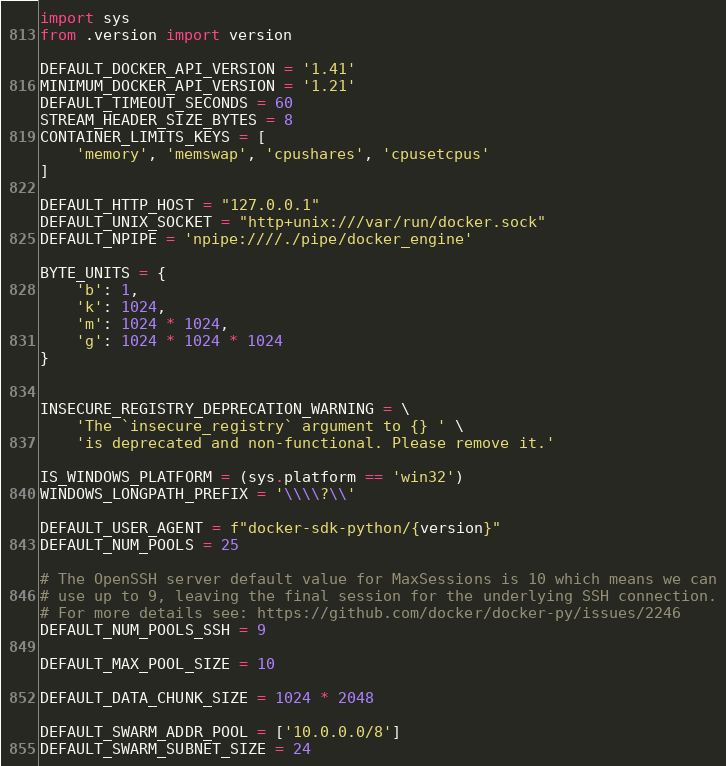Convert code to text. <code><loc_0><loc_0><loc_500><loc_500><_Python_>import sys
from .version import version

DEFAULT_DOCKER_API_VERSION = '1.41'
MINIMUM_DOCKER_API_VERSION = '1.21'
DEFAULT_TIMEOUT_SECONDS = 60
STREAM_HEADER_SIZE_BYTES = 8
CONTAINER_LIMITS_KEYS = [
    'memory', 'memswap', 'cpushares', 'cpusetcpus'
]

DEFAULT_HTTP_HOST = "127.0.0.1"
DEFAULT_UNIX_SOCKET = "http+unix:///var/run/docker.sock"
DEFAULT_NPIPE = 'npipe:////./pipe/docker_engine'

BYTE_UNITS = {
    'b': 1,
    'k': 1024,
    'm': 1024 * 1024,
    'g': 1024 * 1024 * 1024
}


INSECURE_REGISTRY_DEPRECATION_WARNING = \
    'The `insecure_registry` argument to {} ' \
    'is deprecated and non-functional. Please remove it.'

IS_WINDOWS_PLATFORM = (sys.platform == 'win32')
WINDOWS_LONGPATH_PREFIX = '\\\\?\\'

DEFAULT_USER_AGENT = f"docker-sdk-python/{version}"
DEFAULT_NUM_POOLS = 25

# The OpenSSH server default value for MaxSessions is 10 which means we can
# use up to 9, leaving the final session for the underlying SSH connection.
# For more details see: https://github.com/docker/docker-py/issues/2246
DEFAULT_NUM_POOLS_SSH = 9

DEFAULT_MAX_POOL_SIZE = 10

DEFAULT_DATA_CHUNK_SIZE = 1024 * 2048

DEFAULT_SWARM_ADDR_POOL = ['10.0.0.0/8']
DEFAULT_SWARM_SUBNET_SIZE = 24
</code> 